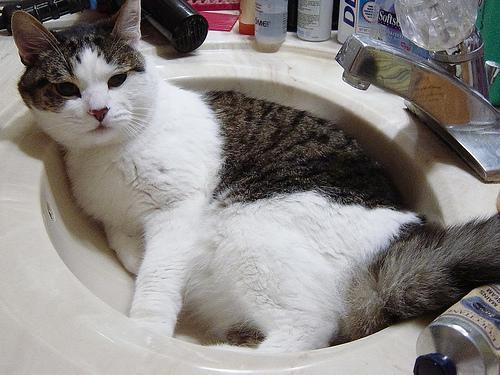How many eyes does the cat have?
Give a very brief answer. 2. How many tails does the cat have?
Give a very brief answer. 1. 